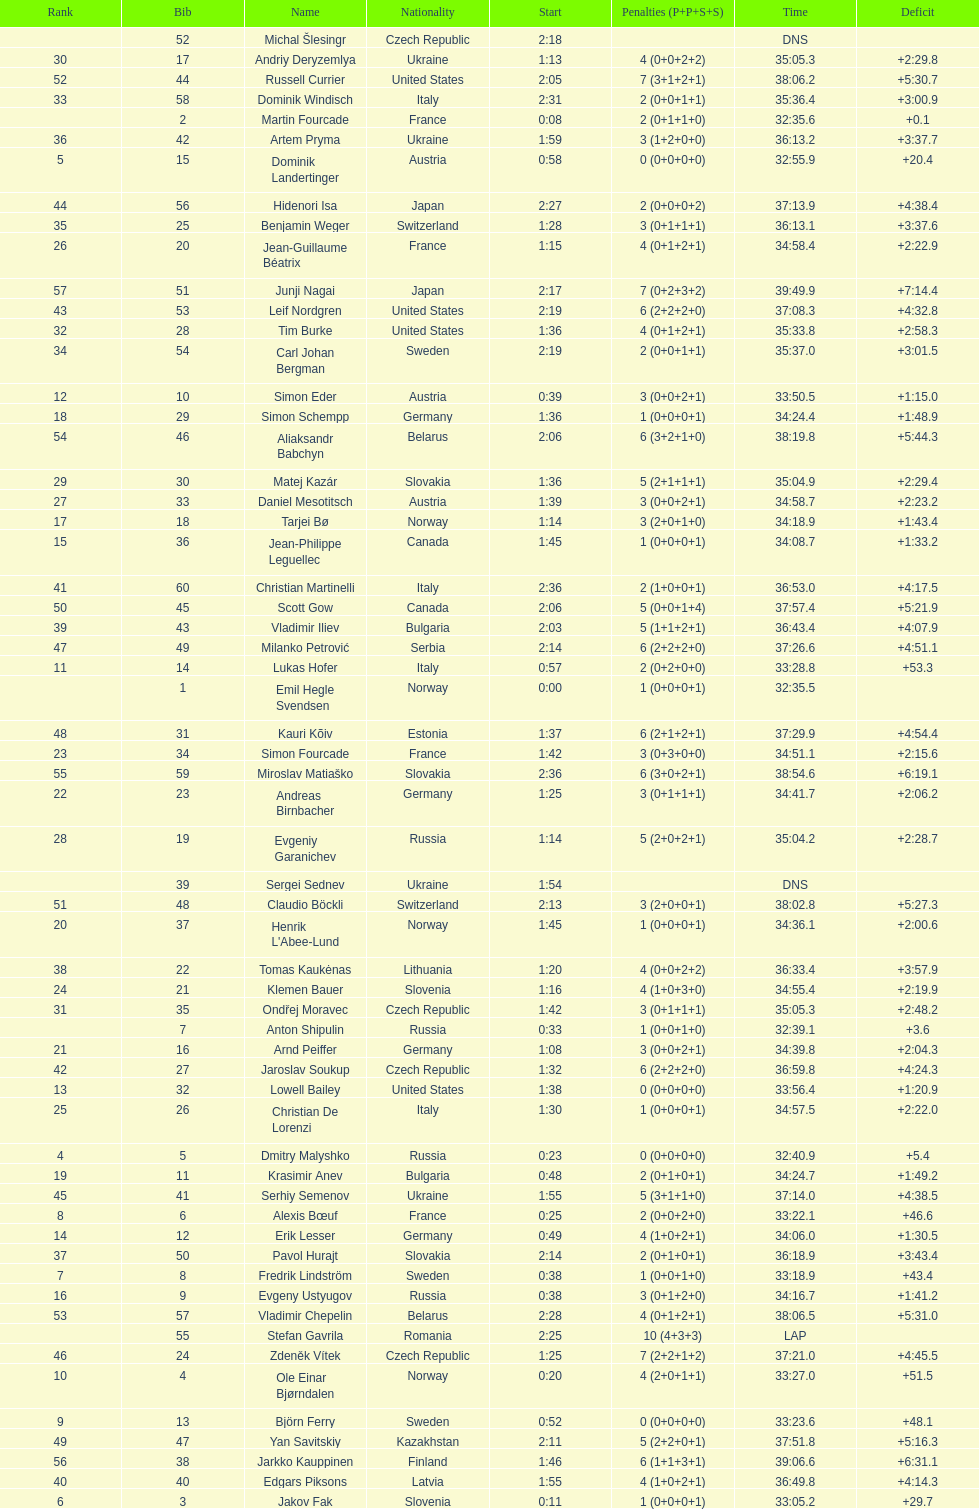Other than burke, name an athlete from the us. Leif Nordgren. 